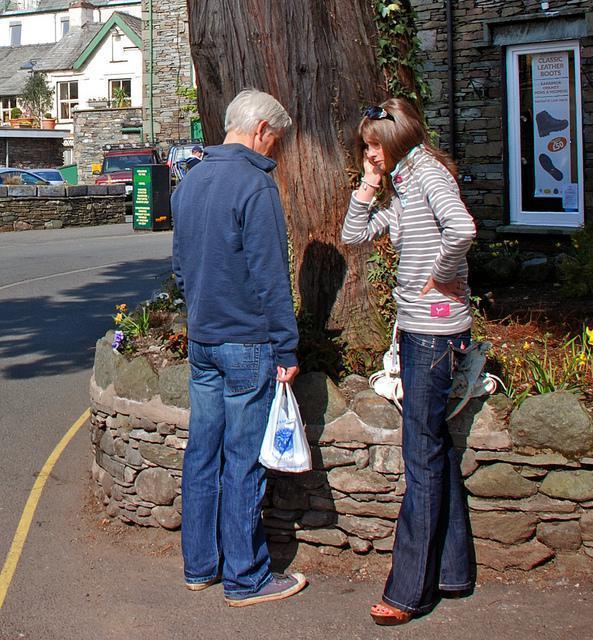What does the woman have in her right hand?
Indicate the correct choice and explain in the format: 'Answer: answer
Rationale: rationale.'
Options: Charger, coins, phone, bible. Answer: phone.
Rationale: The woman has a phone. 